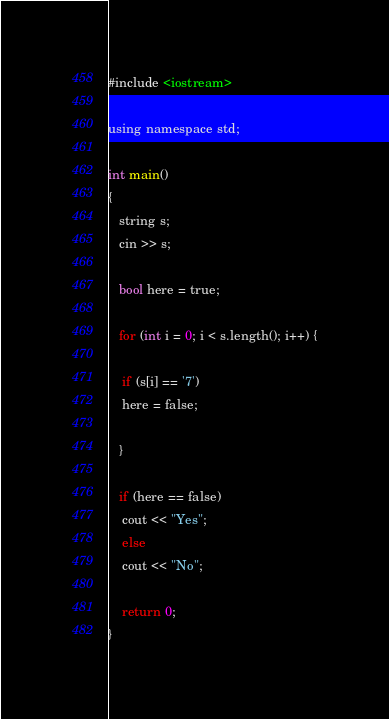Convert code to text. <code><loc_0><loc_0><loc_500><loc_500><_C_>#include <iostream>

using namespace std;

int main()
{
   string s;
   cin >> s;

   bool here = true;

   for (int i = 0; i < s.length(); i++) {

    if (s[i] == '7')
    here = false;

   }

   if (here == false)
    cout << "Yes";
    else
    cout << "No";

    return 0;
}
</code> 